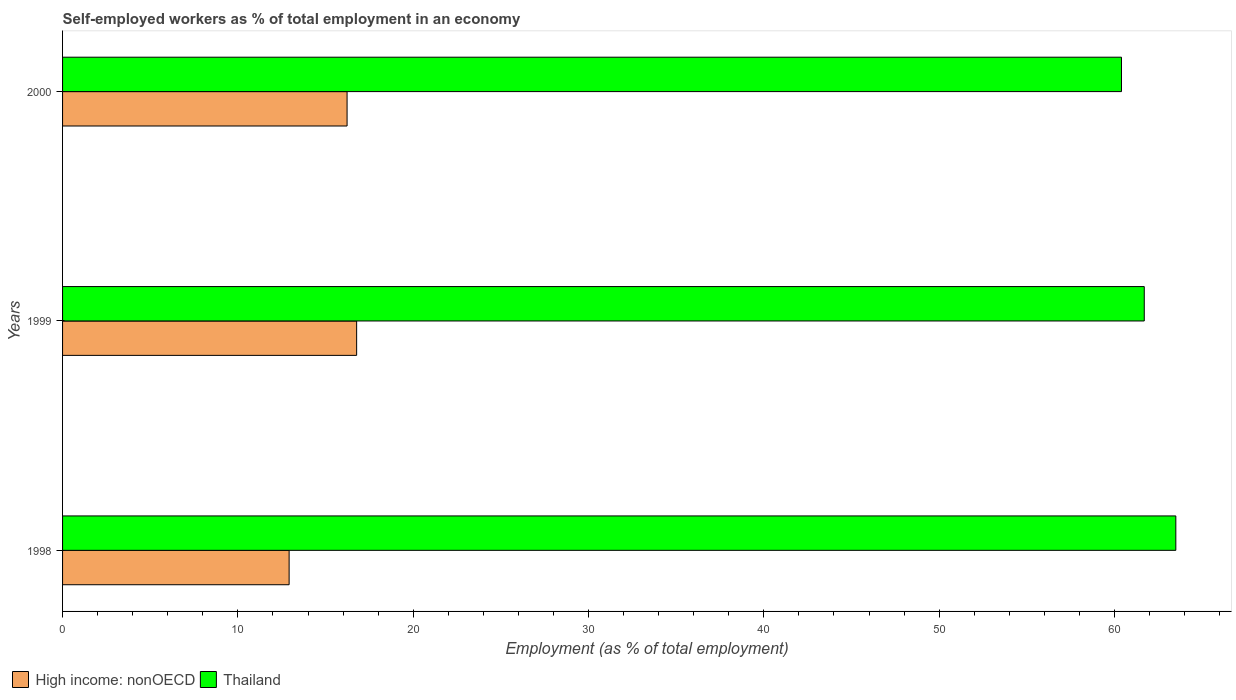How many different coloured bars are there?
Give a very brief answer. 2. Are the number of bars per tick equal to the number of legend labels?
Make the answer very short. Yes. How many bars are there on the 1st tick from the top?
Give a very brief answer. 2. How many bars are there on the 3rd tick from the bottom?
Give a very brief answer. 2. What is the label of the 2nd group of bars from the top?
Offer a very short reply. 1999. In how many cases, is the number of bars for a given year not equal to the number of legend labels?
Your response must be concise. 0. What is the percentage of self-employed workers in Thailand in 1999?
Your answer should be compact. 61.7. Across all years, what is the maximum percentage of self-employed workers in High income: nonOECD?
Your answer should be very brief. 16.77. Across all years, what is the minimum percentage of self-employed workers in Thailand?
Ensure brevity in your answer.  60.4. What is the total percentage of self-employed workers in High income: nonOECD in the graph?
Offer a very short reply. 45.92. What is the difference between the percentage of self-employed workers in High income: nonOECD in 1999 and that in 2000?
Ensure brevity in your answer.  0.55. What is the difference between the percentage of self-employed workers in Thailand in 1998 and the percentage of self-employed workers in High income: nonOECD in 1999?
Give a very brief answer. 46.73. What is the average percentage of self-employed workers in High income: nonOECD per year?
Keep it short and to the point. 15.31. In the year 1998, what is the difference between the percentage of self-employed workers in Thailand and percentage of self-employed workers in High income: nonOECD?
Give a very brief answer. 50.58. What is the ratio of the percentage of self-employed workers in Thailand in 1998 to that in 1999?
Keep it short and to the point. 1.03. Is the difference between the percentage of self-employed workers in Thailand in 1999 and 2000 greater than the difference between the percentage of self-employed workers in High income: nonOECD in 1999 and 2000?
Your answer should be compact. Yes. What is the difference between the highest and the second highest percentage of self-employed workers in High income: nonOECD?
Your answer should be compact. 0.55. What is the difference between the highest and the lowest percentage of self-employed workers in Thailand?
Your response must be concise. 3.1. In how many years, is the percentage of self-employed workers in High income: nonOECD greater than the average percentage of self-employed workers in High income: nonOECD taken over all years?
Your response must be concise. 2. What does the 2nd bar from the top in 1999 represents?
Your answer should be compact. High income: nonOECD. What does the 2nd bar from the bottom in 1998 represents?
Offer a terse response. Thailand. How many years are there in the graph?
Provide a succinct answer. 3. What is the difference between two consecutive major ticks on the X-axis?
Your answer should be very brief. 10. Are the values on the major ticks of X-axis written in scientific E-notation?
Keep it short and to the point. No. Does the graph contain grids?
Your answer should be compact. No. Where does the legend appear in the graph?
Provide a short and direct response. Bottom left. What is the title of the graph?
Your response must be concise. Self-employed workers as % of total employment in an economy. What is the label or title of the X-axis?
Your response must be concise. Employment (as % of total employment). What is the Employment (as % of total employment) in High income: nonOECD in 1998?
Offer a very short reply. 12.92. What is the Employment (as % of total employment) in Thailand in 1998?
Offer a very short reply. 63.5. What is the Employment (as % of total employment) in High income: nonOECD in 1999?
Offer a very short reply. 16.77. What is the Employment (as % of total employment) in Thailand in 1999?
Your answer should be very brief. 61.7. What is the Employment (as % of total employment) in High income: nonOECD in 2000?
Your answer should be compact. 16.23. What is the Employment (as % of total employment) of Thailand in 2000?
Your answer should be very brief. 60.4. Across all years, what is the maximum Employment (as % of total employment) of High income: nonOECD?
Offer a terse response. 16.77. Across all years, what is the maximum Employment (as % of total employment) in Thailand?
Your answer should be very brief. 63.5. Across all years, what is the minimum Employment (as % of total employment) in High income: nonOECD?
Offer a terse response. 12.92. Across all years, what is the minimum Employment (as % of total employment) of Thailand?
Give a very brief answer. 60.4. What is the total Employment (as % of total employment) of High income: nonOECD in the graph?
Provide a short and direct response. 45.92. What is the total Employment (as % of total employment) of Thailand in the graph?
Make the answer very short. 185.6. What is the difference between the Employment (as % of total employment) of High income: nonOECD in 1998 and that in 1999?
Provide a succinct answer. -3.85. What is the difference between the Employment (as % of total employment) in High income: nonOECD in 1998 and that in 2000?
Your answer should be compact. -3.31. What is the difference between the Employment (as % of total employment) of Thailand in 1998 and that in 2000?
Provide a succinct answer. 3.1. What is the difference between the Employment (as % of total employment) in High income: nonOECD in 1999 and that in 2000?
Offer a very short reply. 0.55. What is the difference between the Employment (as % of total employment) of Thailand in 1999 and that in 2000?
Keep it short and to the point. 1.3. What is the difference between the Employment (as % of total employment) in High income: nonOECD in 1998 and the Employment (as % of total employment) in Thailand in 1999?
Give a very brief answer. -48.78. What is the difference between the Employment (as % of total employment) of High income: nonOECD in 1998 and the Employment (as % of total employment) of Thailand in 2000?
Your answer should be very brief. -47.48. What is the difference between the Employment (as % of total employment) in High income: nonOECD in 1999 and the Employment (as % of total employment) in Thailand in 2000?
Your answer should be compact. -43.63. What is the average Employment (as % of total employment) of High income: nonOECD per year?
Provide a succinct answer. 15.31. What is the average Employment (as % of total employment) of Thailand per year?
Your answer should be very brief. 61.87. In the year 1998, what is the difference between the Employment (as % of total employment) of High income: nonOECD and Employment (as % of total employment) of Thailand?
Provide a short and direct response. -50.58. In the year 1999, what is the difference between the Employment (as % of total employment) of High income: nonOECD and Employment (as % of total employment) of Thailand?
Make the answer very short. -44.93. In the year 2000, what is the difference between the Employment (as % of total employment) in High income: nonOECD and Employment (as % of total employment) in Thailand?
Offer a terse response. -44.17. What is the ratio of the Employment (as % of total employment) in High income: nonOECD in 1998 to that in 1999?
Offer a terse response. 0.77. What is the ratio of the Employment (as % of total employment) in Thailand in 1998 to that in 1999?
Give a very brief answer. 1.03. What is the ratio of the Employment (as % of total employment) of High income: nonOECD in 1998 to that in 2000?
Provide a short and direct response. 0.8. What is the ratio of the Employment (as % of total employment) of Thailand in 1998 to that in 2000?
Make the answer very short. 1.05. What is the ratio of the Employment (as % of total employment) in High income: nonOECD in 1999 to that in 2000?
Your response must be concise. 1.03. What is the ratio of the Employment (as % of total employment) in Thailand in 1999 to that in 2000?
Provide a short and direct response. 1.02. What is the difference between the highest and the second highest Employment (as % of total employment) in High income: nonOECD?
Give a very brief answer. 0.55. What is the difference between the highest and the second highest Employment (as % of total employment) of Thailand?
Keep it short and to the point. 1.8. What is the difference between the highest and the lowest Employment (as % of total employment) in High income: nonOECD?
Offer a very short reply. 3.85. 